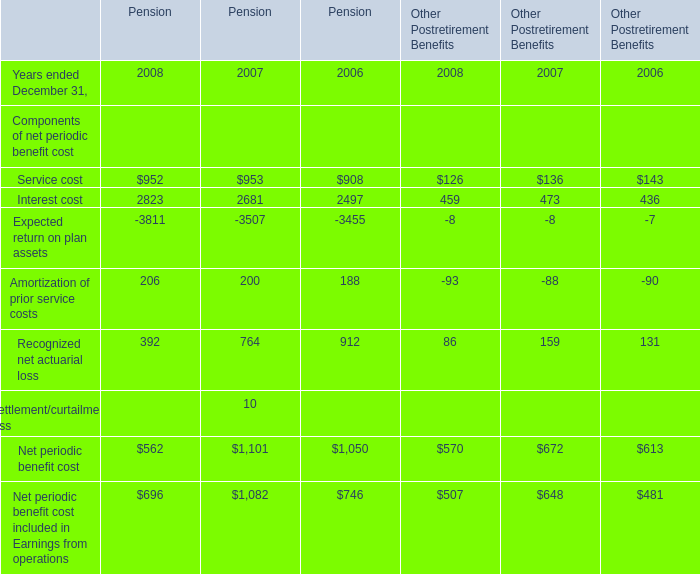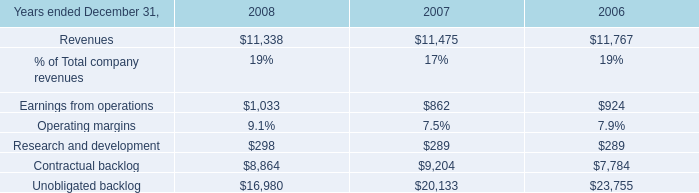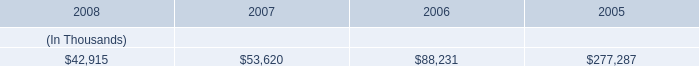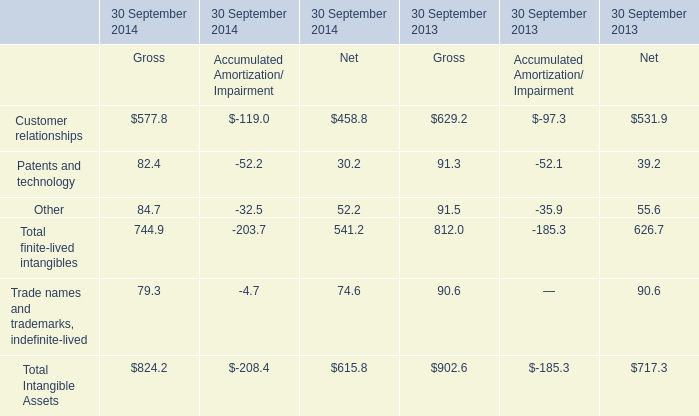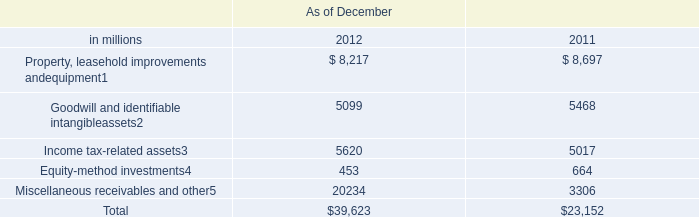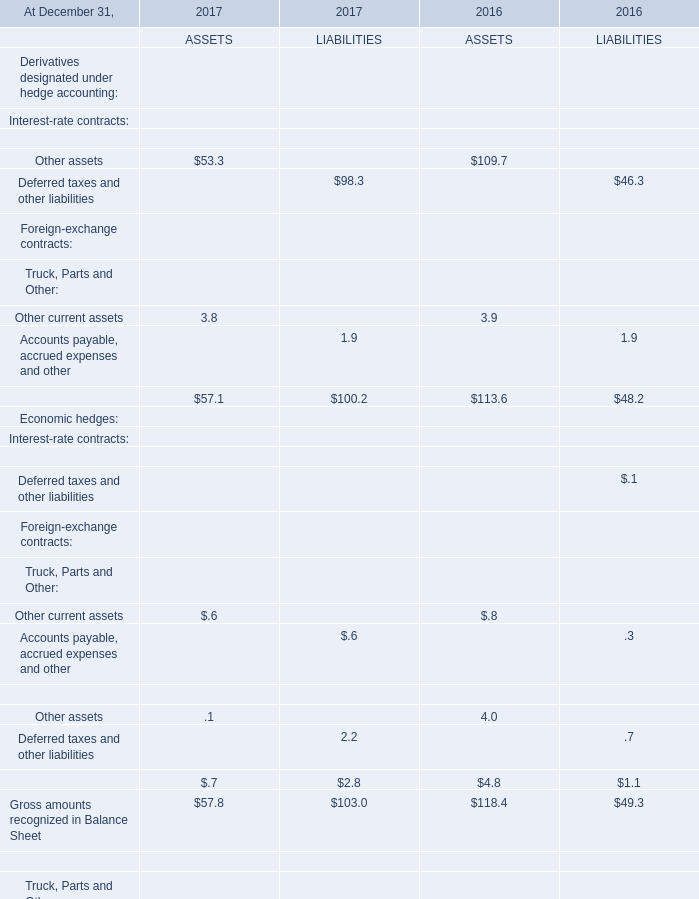what percent of system energy's receivable from the money pool was replaced by a note receivable from entergy new orleans? 
Computations: ((22.5 * 1000) / 53620)
Answer: 0.41962. 